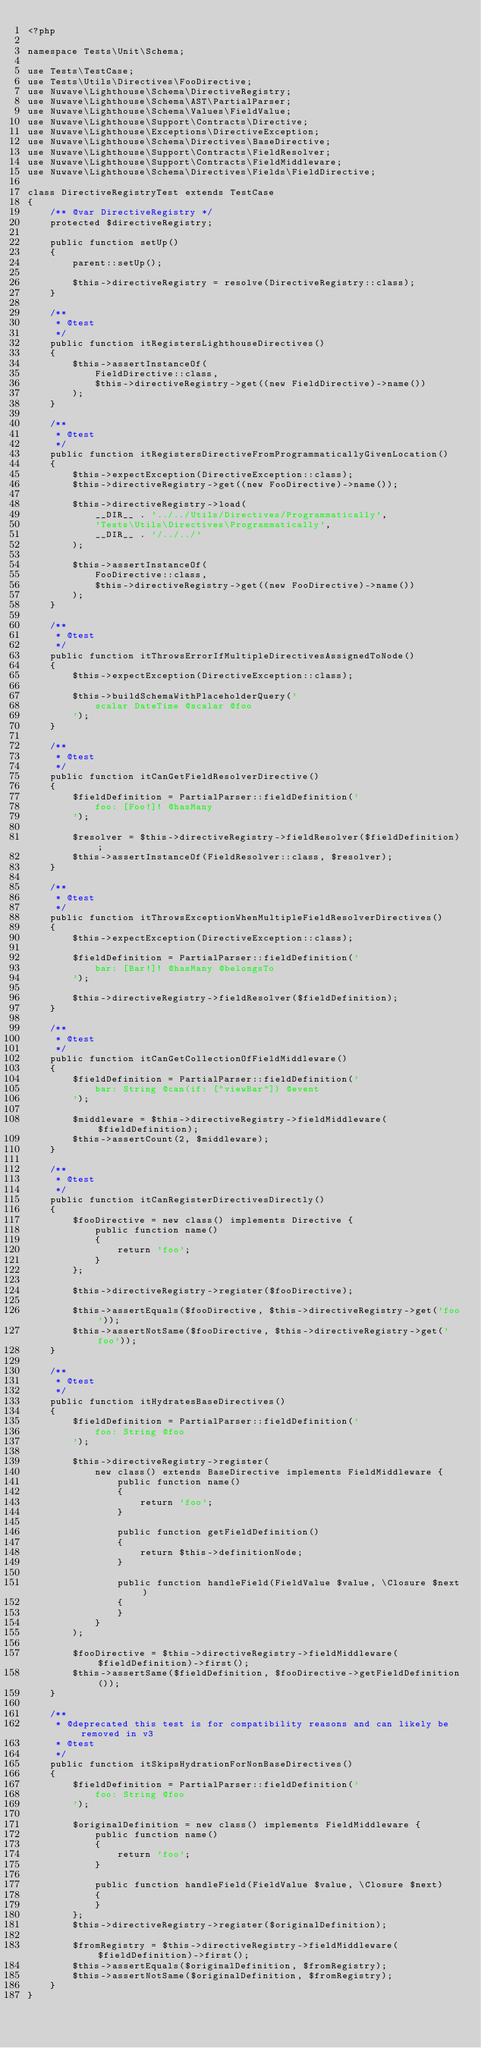<code> <loc_0><loc_0><loc_500><loc_500><_PHP_><?php

namespace Tests\Unit\Schema;

use Tests\TestCase;
use Tests\Utils\Directives\FooDirective;
use Nuwave\Lighthouse\Schema\DirectiveRegistry;
use Nuwave\Lighthouse\Schema\AST\PartialParser;
use Nuwave\Lighthouse\Schema\Values\FieldValue;
use Nuwave\Lighthouse\Support\Contracts\Directive;
use Nuwave\Lighthouse\Exceptions\DirectiveException;
use Nuwave\Lighthouse\Schema\Directives\BaseDirective;
use Nuwave\Lighthouse\Support\Contracts\FieldResolver;
use Nuwave\Lighthouse\Support\Contracts\FieldMiddleware;
use Nuwave\Lighthouse\Schema\Directives\Fields\FieldDirective;

class DirectiveRegistryTest extends TestCase
{
    /** @var DirectiveRegistry */
    protected $directiveRegistry;

    public function setUp()
    {
        parent::setUp();

        $this->directiveRegistry = resolve(DirectiveRegistry::class);
    }

    /**
     * @test
     */
    public function itRegistersLighthouseDirectives()
    {
        $this->assertInstanceOf(
            FieldDirective::class,
            $this->directiveRegistry->get((new FieldDirective)->name())
        );
    }
    
    /**
     * @test
     */
    public function itRegistersDirectiveFromProgrammaticallyGivenLocation()
    {
        $this->expectException(DirectiveException::class);
        $this->directiveRegistry->get((new FooDirective)->name());
        
        $this->directiveRegistry->load(
            __DIR__ . '../../Utils/Directives/Programmatically',
            'Tests\Utils\Directives\Programmatically',
            __DIR__ . '/../../'
        );
        
        $this->assertInstanceOf(
            FooDirective::class,
            $this->directiveRegistry->get((new FooDirective)->name())
        );
    }

    /**
     * @test
     */
    public function itThrowsErrorIfMultipleDirectivesAssignedToNode()
    {
        $this->expectException(DirectiveException::class);

        $this->buildSchemaWithPlaceholderQuery('
            scalar DateTime @scalar @foo
        ');
    }

    /**
     * @test
     */
    public function itCanGetFieldResolverDirective()
    {
        $fieldDefinition = PartialParser::fieldDefinition('
            foo: [Foo!]! @hasMany
        ');

        $resolver = $this->directiveRegistry->fieldResolver($fieldDefinition);
        $this->assertInstanceOf(FieldResolver::class, $resolver);
    }

    /**
     * @test
     */
    public function itThrowsExceptionWhenMultipleFieldResolverDirectives()
    {
        $this->expectException(DirectiveException::class);

        $fieldDefinition = PartialParser::fieldDefinition('
            bar: [Bar!]! @hasMany @belongsTo
        ');

        $this->directiveRegistry->fieldResolver($fieldDefinition);
    }

    /**
     * @test
     */
    public function itCanGetCollectionOfFieldMiddleware()
    {
        $fieldDefinition = PartialParser::fieldDefinition('
            bar: String @can(if: ["viewBar"]) @event
        ');

        $middleware = $this->directiveRegistry->fieldMiddleware($fieldDefinition);
        $this->assertCount(2, $middleware);
    }

    /**
     * @test
     */
    public function itCanRegisterDirectivesDirectly()
    {
        $fooDirective = new class() implements Directive {
            public function name()
            {
                return 'foo';
            }
        };

        $this->directiveRegistry->register($fooDirective);

        $this->assertEquals($fooDirective, $this->directiveRegistry->get('foo'));
        $this->assertNotSame($fooDirective, $this->directiveRegistry->get('foo'));
    }

    /**
     * @test
     */
    public function itHydratesBaseDirectives()
    {
        $fieldDefinition = PartialParser::fieldDefinition('
            foo: String @foo
        ');

        $this->directiveRegistry->register(
            new class() extends BaseDirective implements FieldMiddleware {
                public function name()
                {
                    return 'foo';
                }

                public function getFieldDefinition()
                {
                    return $this->definitionNode;
                }

                public function handleField(FieldValue $value, \Closure $next)
                {
                }
            }
        );

        $fooDirective = $this->directiveRegistry->fieldMiddleware($fieldDefinition)->first();
        $this->assertSame($fieldDefinition, $fooDirective->getFieldDefinition());
    }

    /**
     * @deprecated this test is for compatibility reasons and can likely be removed in v3
     * @test
     */
    public function itSkipsHydrationForNonBaseDirectives()
    {
        $fieldDefinition = PartialParser::fieldDefinition('
            foo: String @foo
        ');

        $originalDefinition = new class() implements FieldMiddleware {
            public function name()
            {
                return 'foo';
            }

            public function handleField(FieldValue $value, \Closure $next)
            {
            }
        };
        $this->directiveRegistry->register($originalDefinition);

        $fromRegistry = $this->directiveRegistry->fieldMiddleware($fieldDefinition)->first();
        $this->assertEquals($originalDefinition, $fromRegistry);
        $this->assertNotSame($originalDefinition, $fromRegistry);
    }
}
</code> 